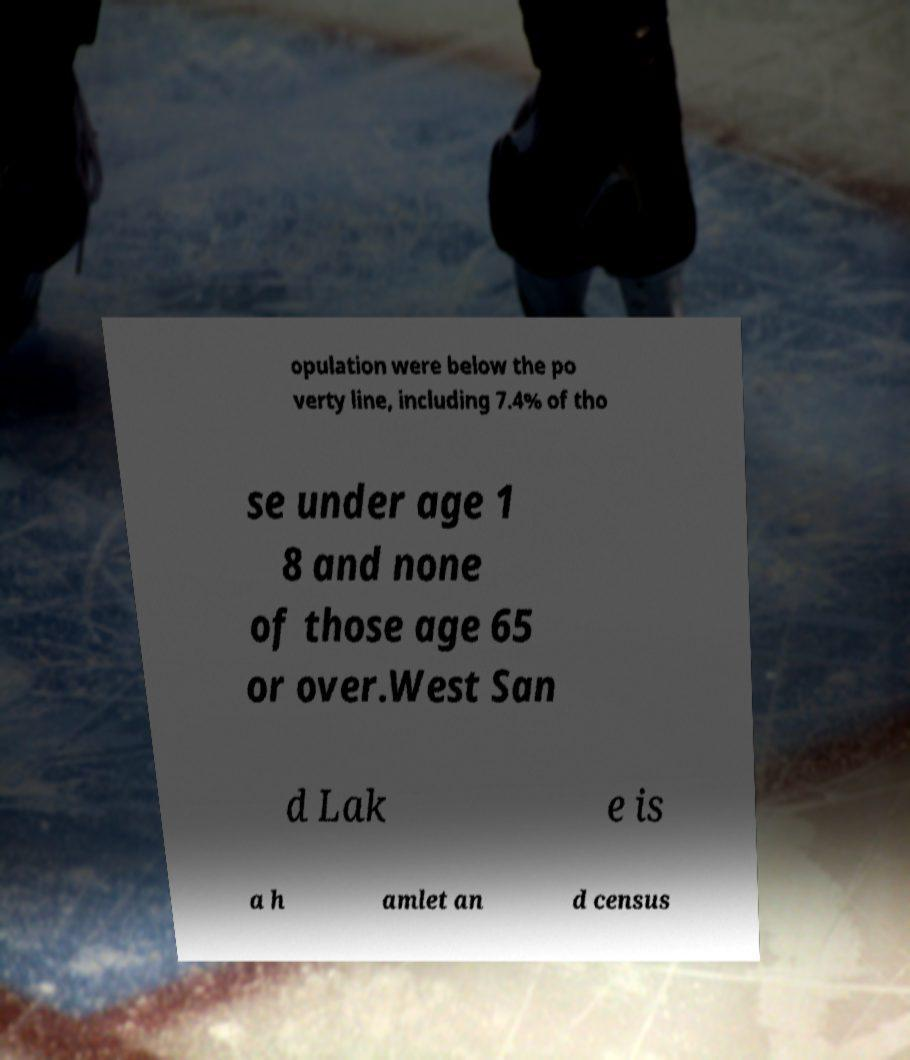What messages or text are displayed in this image? I need them in a readable, typed format. opulation were below the po verty line, including 7.4% of tho se under age 1 8 and none of those age 65 or over.West San d Lak e is a h amlet an d census 